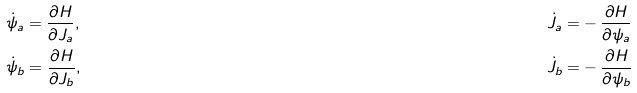<formula> <loc_0><loc_0><loc_500><loc_500>& \dot { \psi } _ { a } = \frac { \partial H } { \partial { J _ { a } } } , & \dot { J } _ { a } = & - \frac { \partial H } { \partial { \psi _ { a } } } \\ & \dot { \psi } _ { b } = \frac { \partial H } { \partial { J _ { b } } } , & \dot { J } _ { b } = & - \frac { \partial H } { \partial { \psi _ { b } } }</formula> 